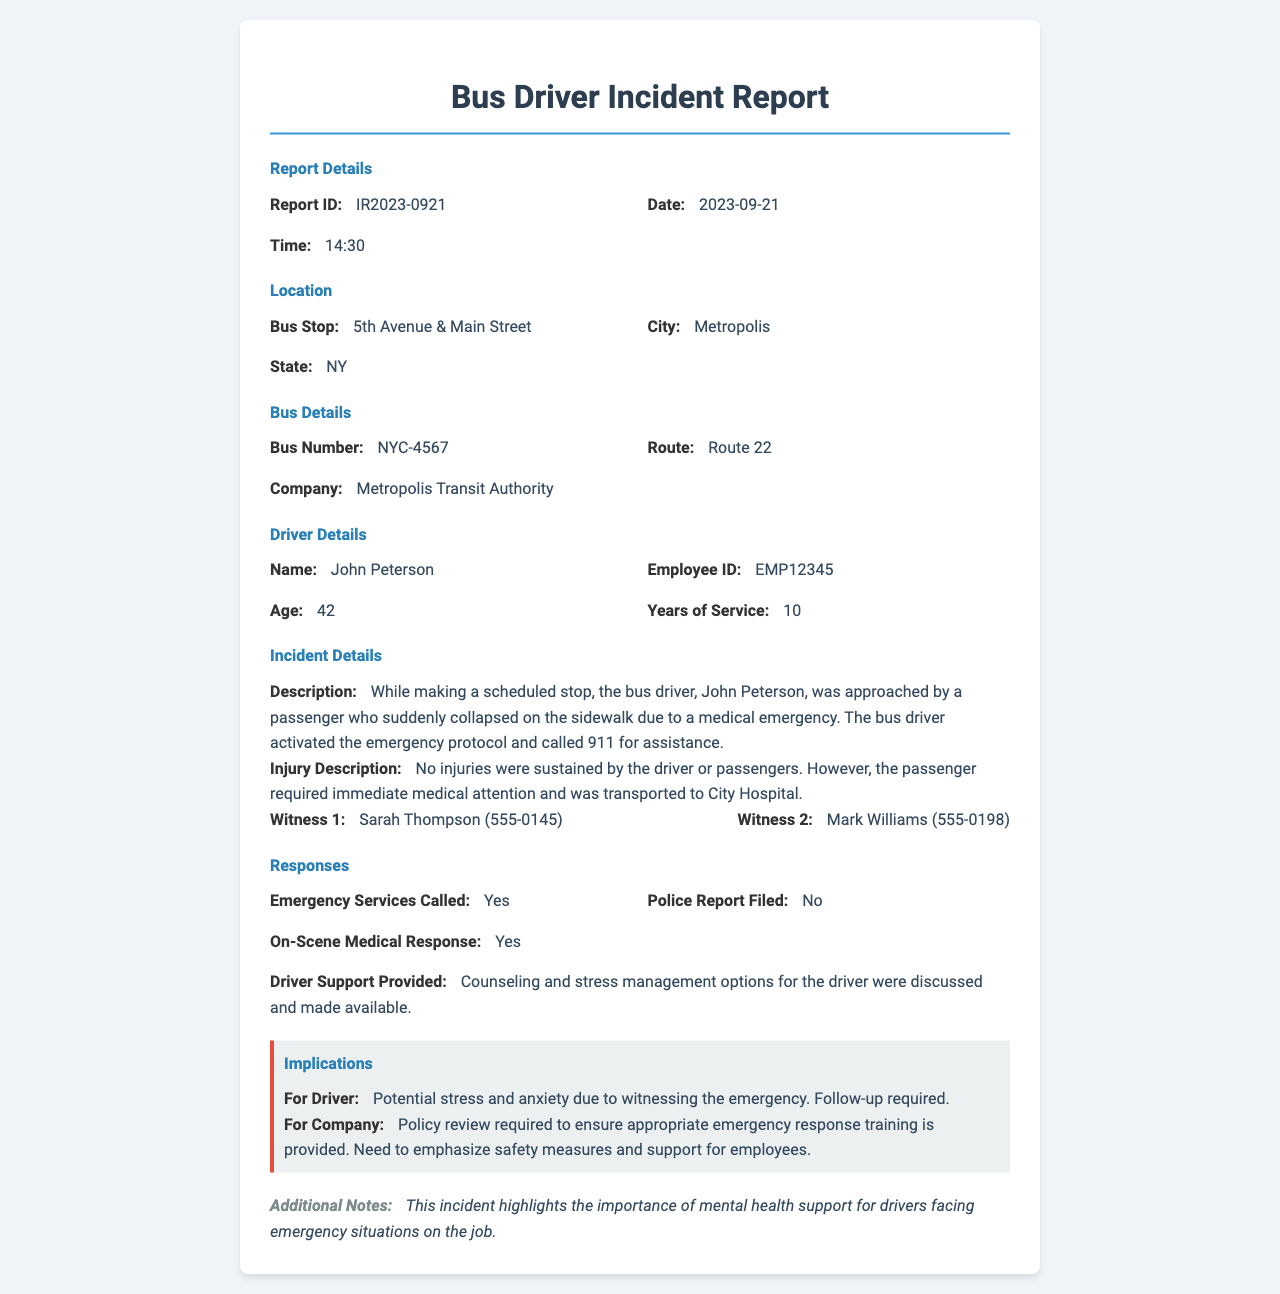What is the report ID? The report ID is a unique identifier for this incident report as noted in the document.
Answer: IR2023-0921 Who is the driver involved in the incident? The driver's name is provided in the driver details section of the report.
Answer: John Peterson What time did the incident occur? The time listed in the report details section indicates when the incident was reported.
Answer: 14:30 What was the location of the incident? The location details provide the bus stop and city where the incident occurred.
Answer: 5th Avenue & Main Street, Metropolis What was the bus number? The bus number is a specific identifier for the vehicle involved in the incident as mentioned in the bus details section.
Answer: NYC-4567 What follow-up was required for the driver? This information is related to the implications for the driver based on the incident.
Answer: Follow-up required What services were called for the incident? The response section indicates the actions taken during the incident, including emergency services.
Answer: Yes What support was provided to the driver? The response section describes the type of support offered to the driver after the incident.
Answer: Counseling and stress management options What is a key takeaway noted in the additional notes? The additional notes highlight an important aspect related to the incident's context and support for the driver.
Answer: Importance of mental health support 